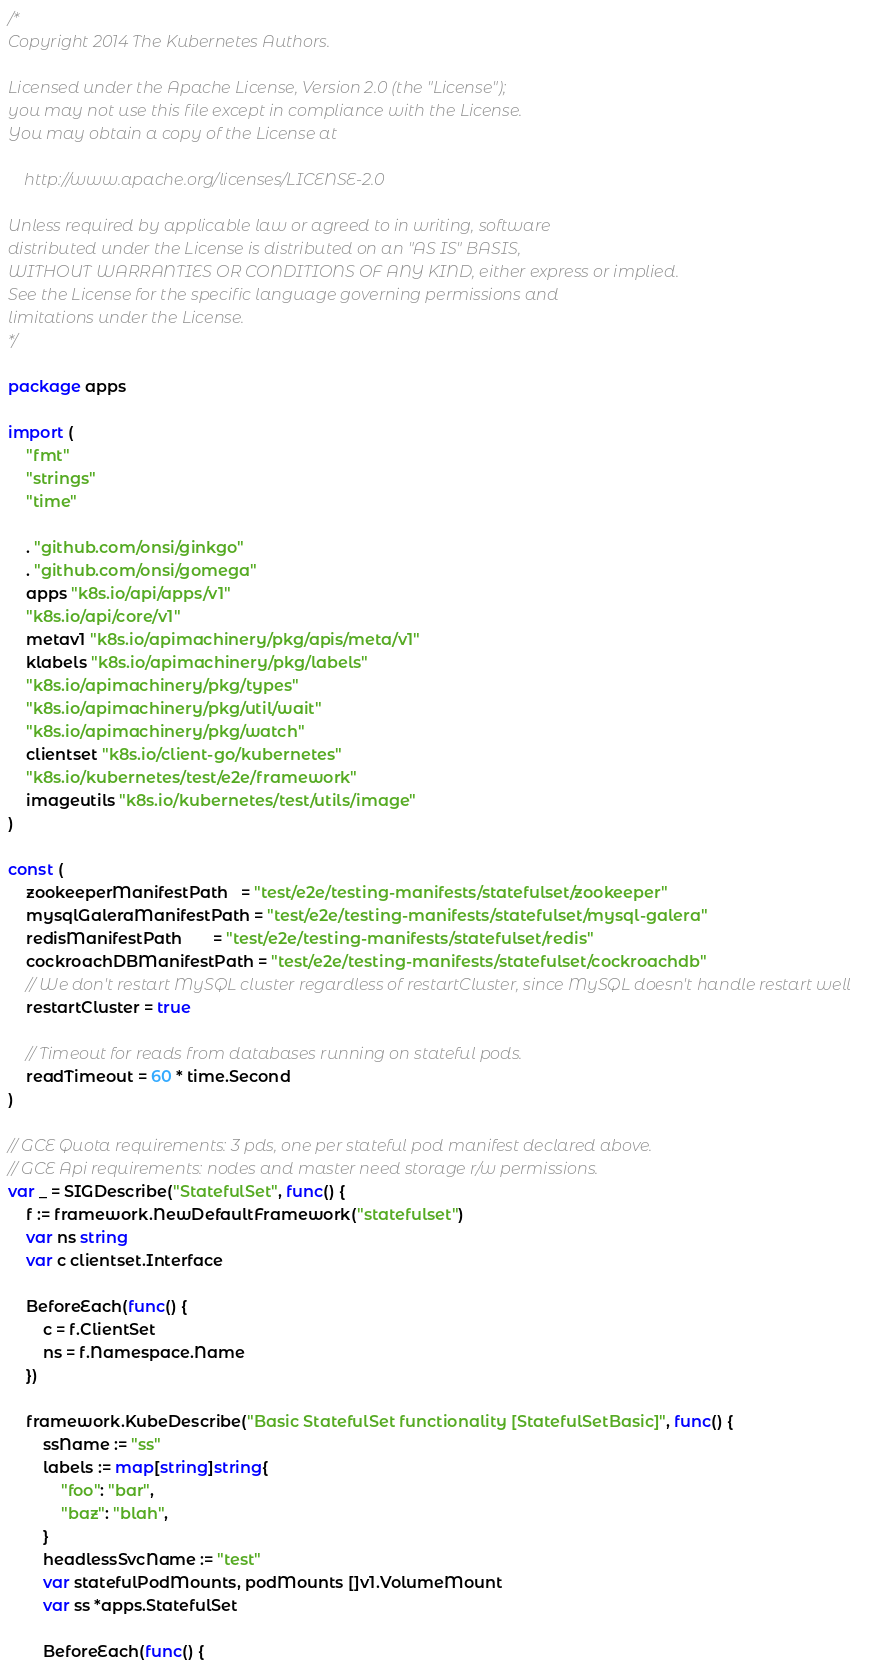Convert code to text. <code><loc_0><loc_0><loc_500><loc_500><_Go_>/*
Copyright 2014 The Kubernetes Authors.

Licensed under the Apache License, Version 2.0 (the "License");
you may not use this file except in compliance with the License.
You may obtain a copy of the License at

    http://www.apache.org/licenses/LICENSE-2.0

Unless required by applicable law or agreed to in writing, software
distributed under the License is distributed on an "AS IS" BASIS,
WITHOUT WARRANTIES OR CONDITIONS OF ANY KIND, either express or implied.
See the License for the specific language governing permissions and
limitations under the License.
*/

package apps

import (
	"fmt"
	"strings"
	"time"

	. "github.com/onsi/ginkgo"
	. "github.com/onsi/gomega"
	apps "k8s.io/api/apps/v1"
	"k8s.io/api/core/v1"
	metav1 "k8s.io/apimachinery/pkg/apis/meta/v1"
	klabels "k8s.io/apimachinery/pkg/labels"
	"k8s.io/apimachinery/pkg/types"
	"k8s.io/apimachinery/pkg/util/wait"
	"k8s.io/apimachinery/pkg/watch"
	clientset "k8s.io/client-go/kubernetes"
	"k8s.io/kubernetes/test/e2e/framework"
	imageutils "k8s.io/kubernetes/test/utils/image"
)

const (
	zookeeperManifestPath   = "test/e2e/testing-manifests/statefulset/zookeeper"
	mysqlGaleraManifestPath = "test/e2e/testing-manifests/statefulset/mysql-galera"
	redisManifestPath       = "test/e2e/testing-manifests/statefulset/redis"
	cockroachDBManifestPath = "test/e2e/testing-manifests/statefulset/cockroachdb"
	// We don't restart MySQL cluster regardless of restartCluster, since MySQL doesn't handle restart well
	restartCluster = true

	// Timeout for reads from databases running on stateful pods.
	readTimeout = 60 * time.Second
)

// GCE Quota requirements: 3 pds, one per stateful pod manifest declared above.
// GCE Api requirements: nodes and master need storage r/w permissions.
var _ = SIGDescribe("StatefulSet", func() {
	f := framework.NewDefaultFramework("statefulset")
	var ns string
	var c clientset.Interface

	BeforeEach(func() {
		c = f.ClientSet
		ns = f.Namespace.Name
	})

	framework.KubeDescribe("Basic StatefulSet functionality [StatefulSetBasic]", func() {
		ssName := "ss"
		labels := map[string]string{
			"foo": "bar",
			"baz": "blah",
		}
		headlessSvcName := "test"
		var statefulPodMounts, podMounts []v1.VolumeMount
		var ss *apps.StatefulSet

		BeforeEach(func() {</code> 